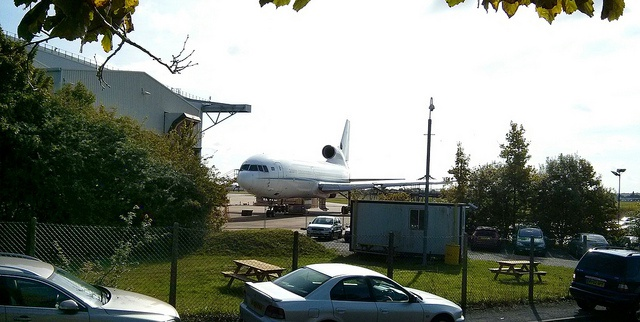Describe the objects in this image and their specific colors. I can see car in lightblue, black, blue, white, and gray tones, car in lightblue, black, lightgray, darkgray, and gray tones, airplane in lightblue, white, gray, darkgray, and black tones, car in lightblue, black, lightgray, and gray tones, and bench in lightblue, black, darkgreen, tan, and gray tones in this image. 